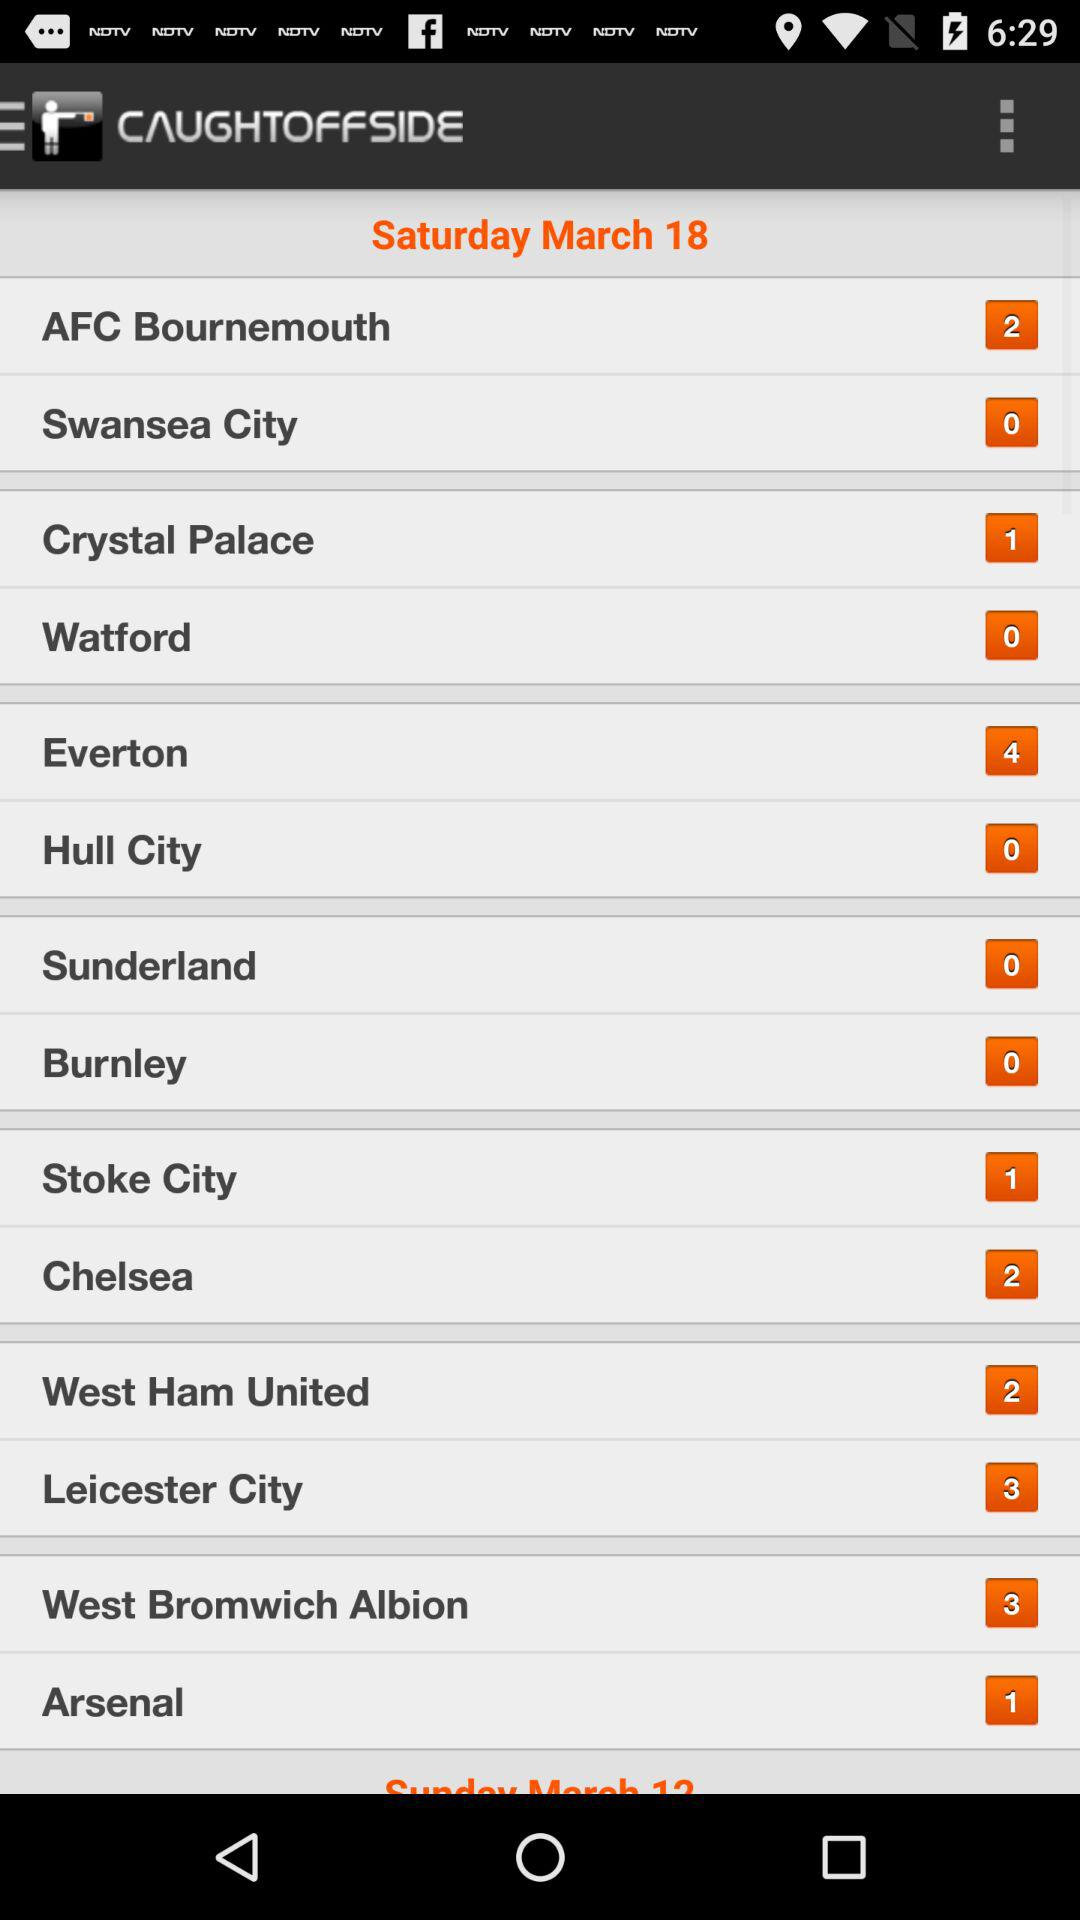What is the mentioned date? The mentioned date is Saturday, March 18. 